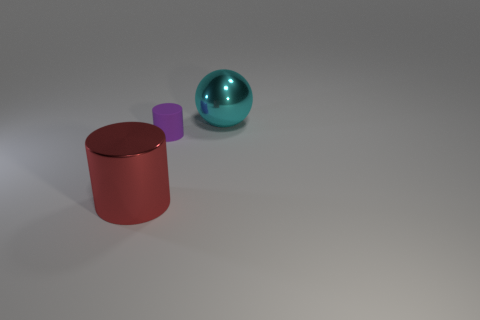Does the large metal sphere have the same color as the large thing on the left side of the matte object?
Provide a short and direct response. No. Are there more large metallic objects on the right side of the small thing than small yellow spheres?
Your answer should be compact. Yes. There is a metal thing that is behind the big metal object that is left of the big cyan metallic object; what number of rubber cylinders are in front of it?
Your response must be concise. 1. Does the big shiny thing that is on the left side of the large cyan metal object have the same shape as the big cyan thing?
Your response must be concise. No. There is a purple cylinder that is in front of the shiny ball; what is it made of?
Your response must be concise. Rubber. What is the material of the purple object?
Offer a terse response. Rubber. What number of spheres are large red matte things or large cyan things?
Provide a succinct answer. 1. Do the large cyan thing and the tiny purple thing have the same material?
Your answer should be very brief. No. The other thing that is the same shape as the small purple object is what size?
Your answer should be compact. Large. There is a thing that is on the left side of the ball and to the right of the large red metallic object; what material is it?
Ensure brevity in your answer.  Rubber. 